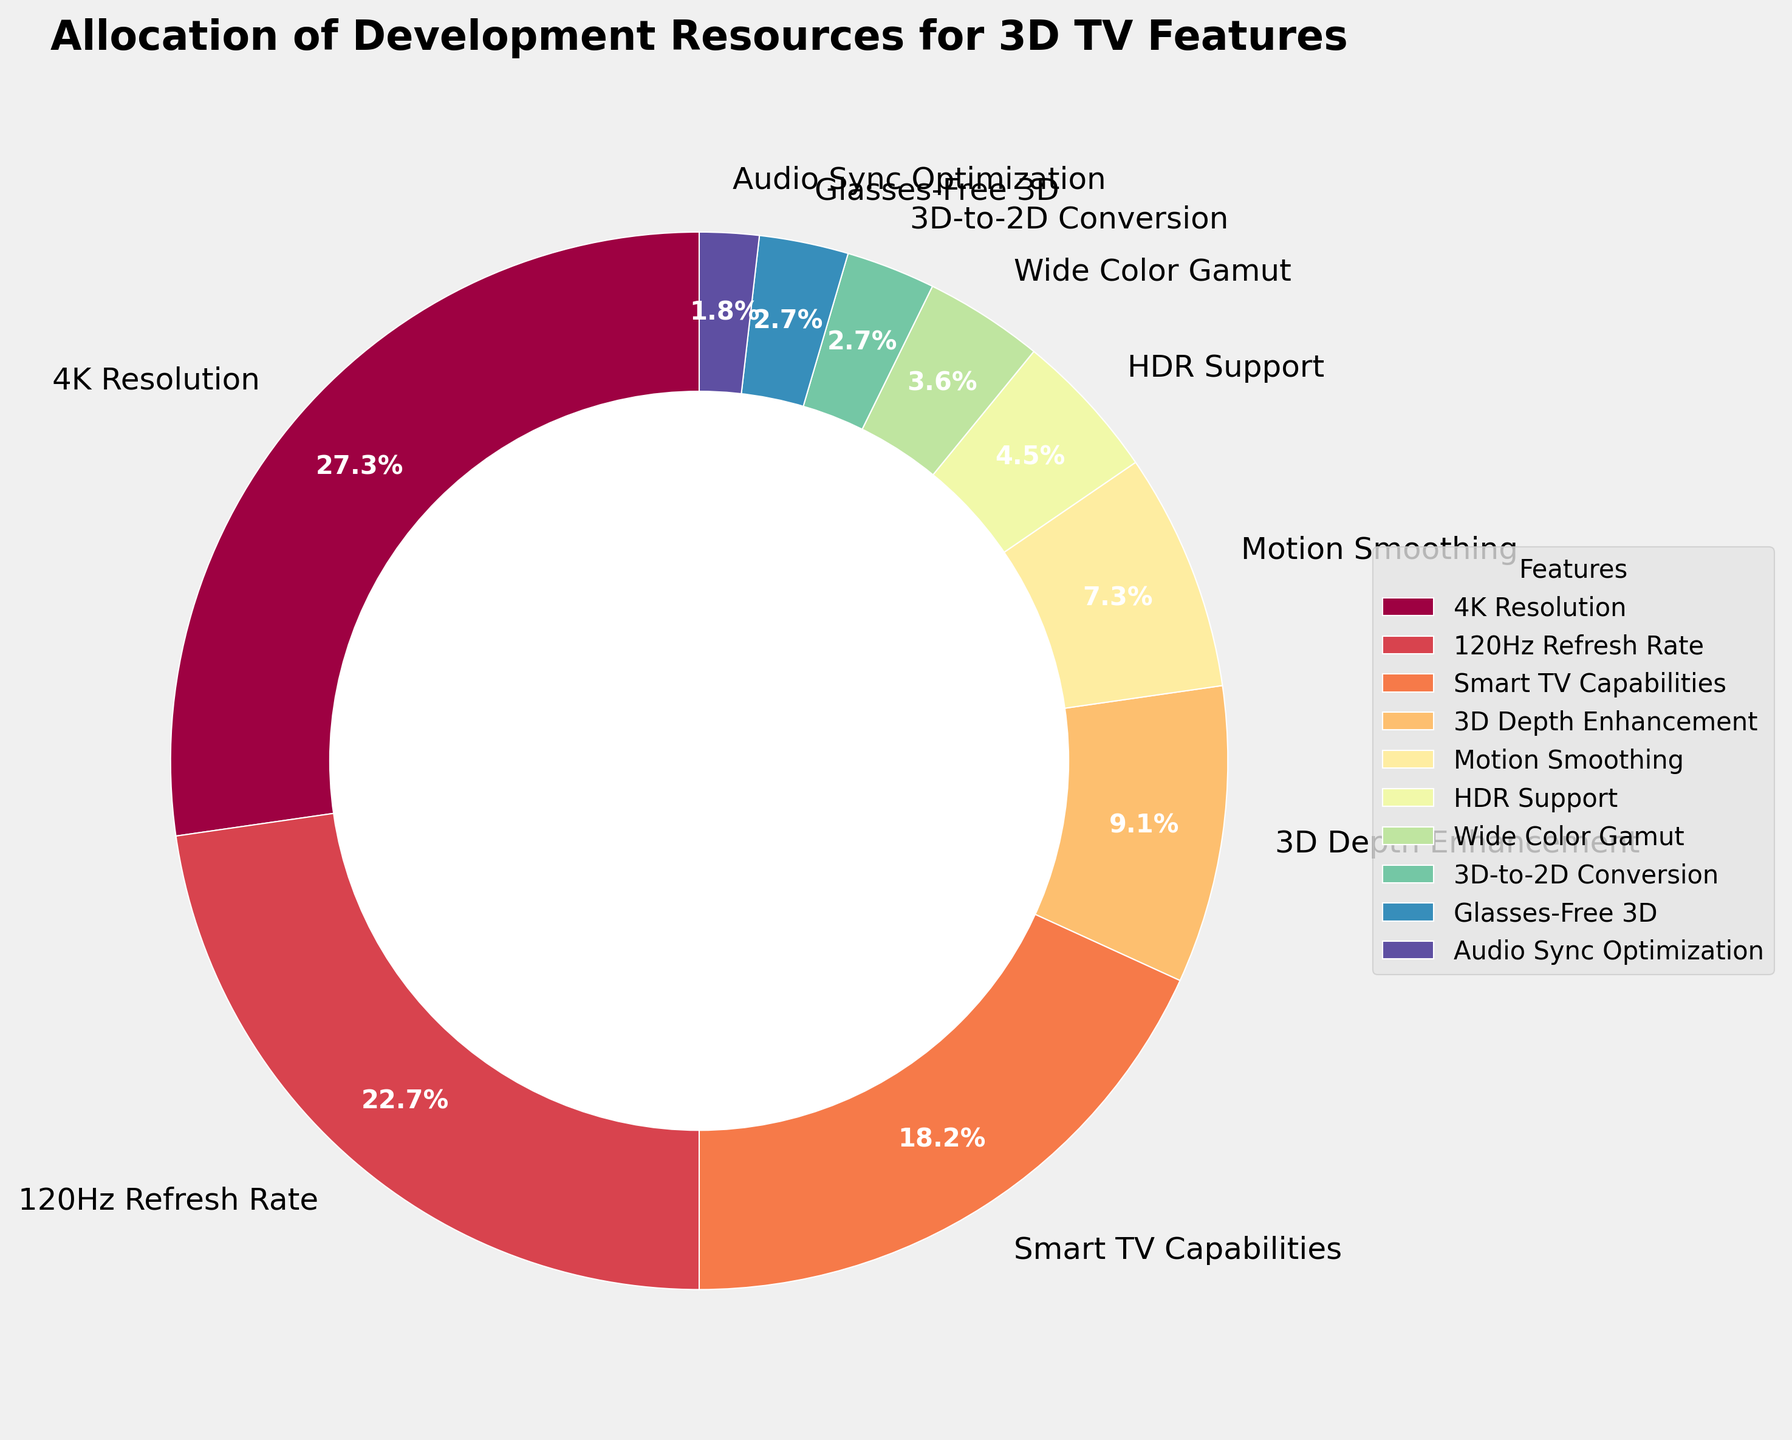Which feature has the highest allocation of development resources? To answer this, look at the pie chart and identify the feature with the largest segment. The label and percentage next to the largest segment will show the feature with the highest allocation.
Answer: 4K Resolution By how much does the allocation for 4K Resolution exceed the allocation for HDR Support? To find this, subtract the percentage value of HDR Support from that of 4K Resolution (30% - 5%).
Answer: 25% What is the combined allocation for Smart TV Capabilities and Motion Smoothing? Add the percentages of Smart TV Capabilities and Motion Smoothing (20% + 8%).
Answer: 28% How does the allocation for 120Hz Refresh Rate compare to the allocation for 3D Depth Enhancement? Compare their percentages directly, where 120Hz Refresh Rate is 25% and 3D Depth Enhancement is 10%. The allocation for 120Hz Refresh Rate is more than double that of 3D Depth Enhancement.
Answer: More than double What visual feature is used to distinguish different segments in the pie chart? Observe the colors used in the segments of the pie chart; each segment is represented with a different color.
Answer: Different colors Which three features have the lowest allocation of development resources? Look at the smallest segments in the pie chart and their labels, which indicate the features and their percentages: Audio Sync Optimization (2%), Glasses-Free 3D (3%), and 3D-to-2D Conversion (3%).
Answer: Audio Sync Optimization, 3D-to-2D Conversion, Glasses-Free 3D What is the total allocation for features related to 3D technology (i.e., 3D Depth Enhancement, 3D-to-2D Conversion, and Glasses-Free 3D)? Add the percentages of 3D Depth Enhancement, 3D-to-2D Conversion, and Glasses-Free 3D (10% + 3% + 3%).
Answer: 16% If development resources for Motion Smoothing were reallocated entirely to Wide Color Gamut, what would the new percentage allocation for Wide Color Gamut be? Add the percentages of Motion Smoothing and Wide Color Gamut (8% + 4%).
Answer: 12% Which feature has a percent allocation closest to the average percent allocation of all features? First, compute the average percentage: (30 + 25 + 20 + 10 + 8 + 5 + 4 + 3 + 3 + 2) / 10 = 11%. Then, find the feature with a percentage closest to 11%, which is 3D Depth Enhancement at 10%.
Answer: 3D Depth Enhancement How is the hierarchy of feature importance visually represented in the chart? The size of each segment in the pie chart represents the proportion of development resources allocated to each feature. Larger segments indicate higher importance, smaller segments indicate lower importance.
Answer: Segment size 